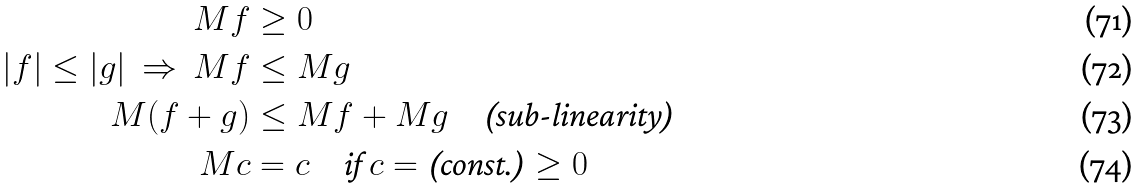Convert formula to latex. <formula><loc_0><loc_0><loc_500><loc_500>M f & \geq 0 \\ | f | \leq | g | \ \Rightarrow \ M f & \leq M g \\ M ( f + g ) & \leq M f + M g \quad \text {(sub-linearity)} \\ M c & = c \quad \text {if $c = \text {(const.)} \geq 0$}</formula> 